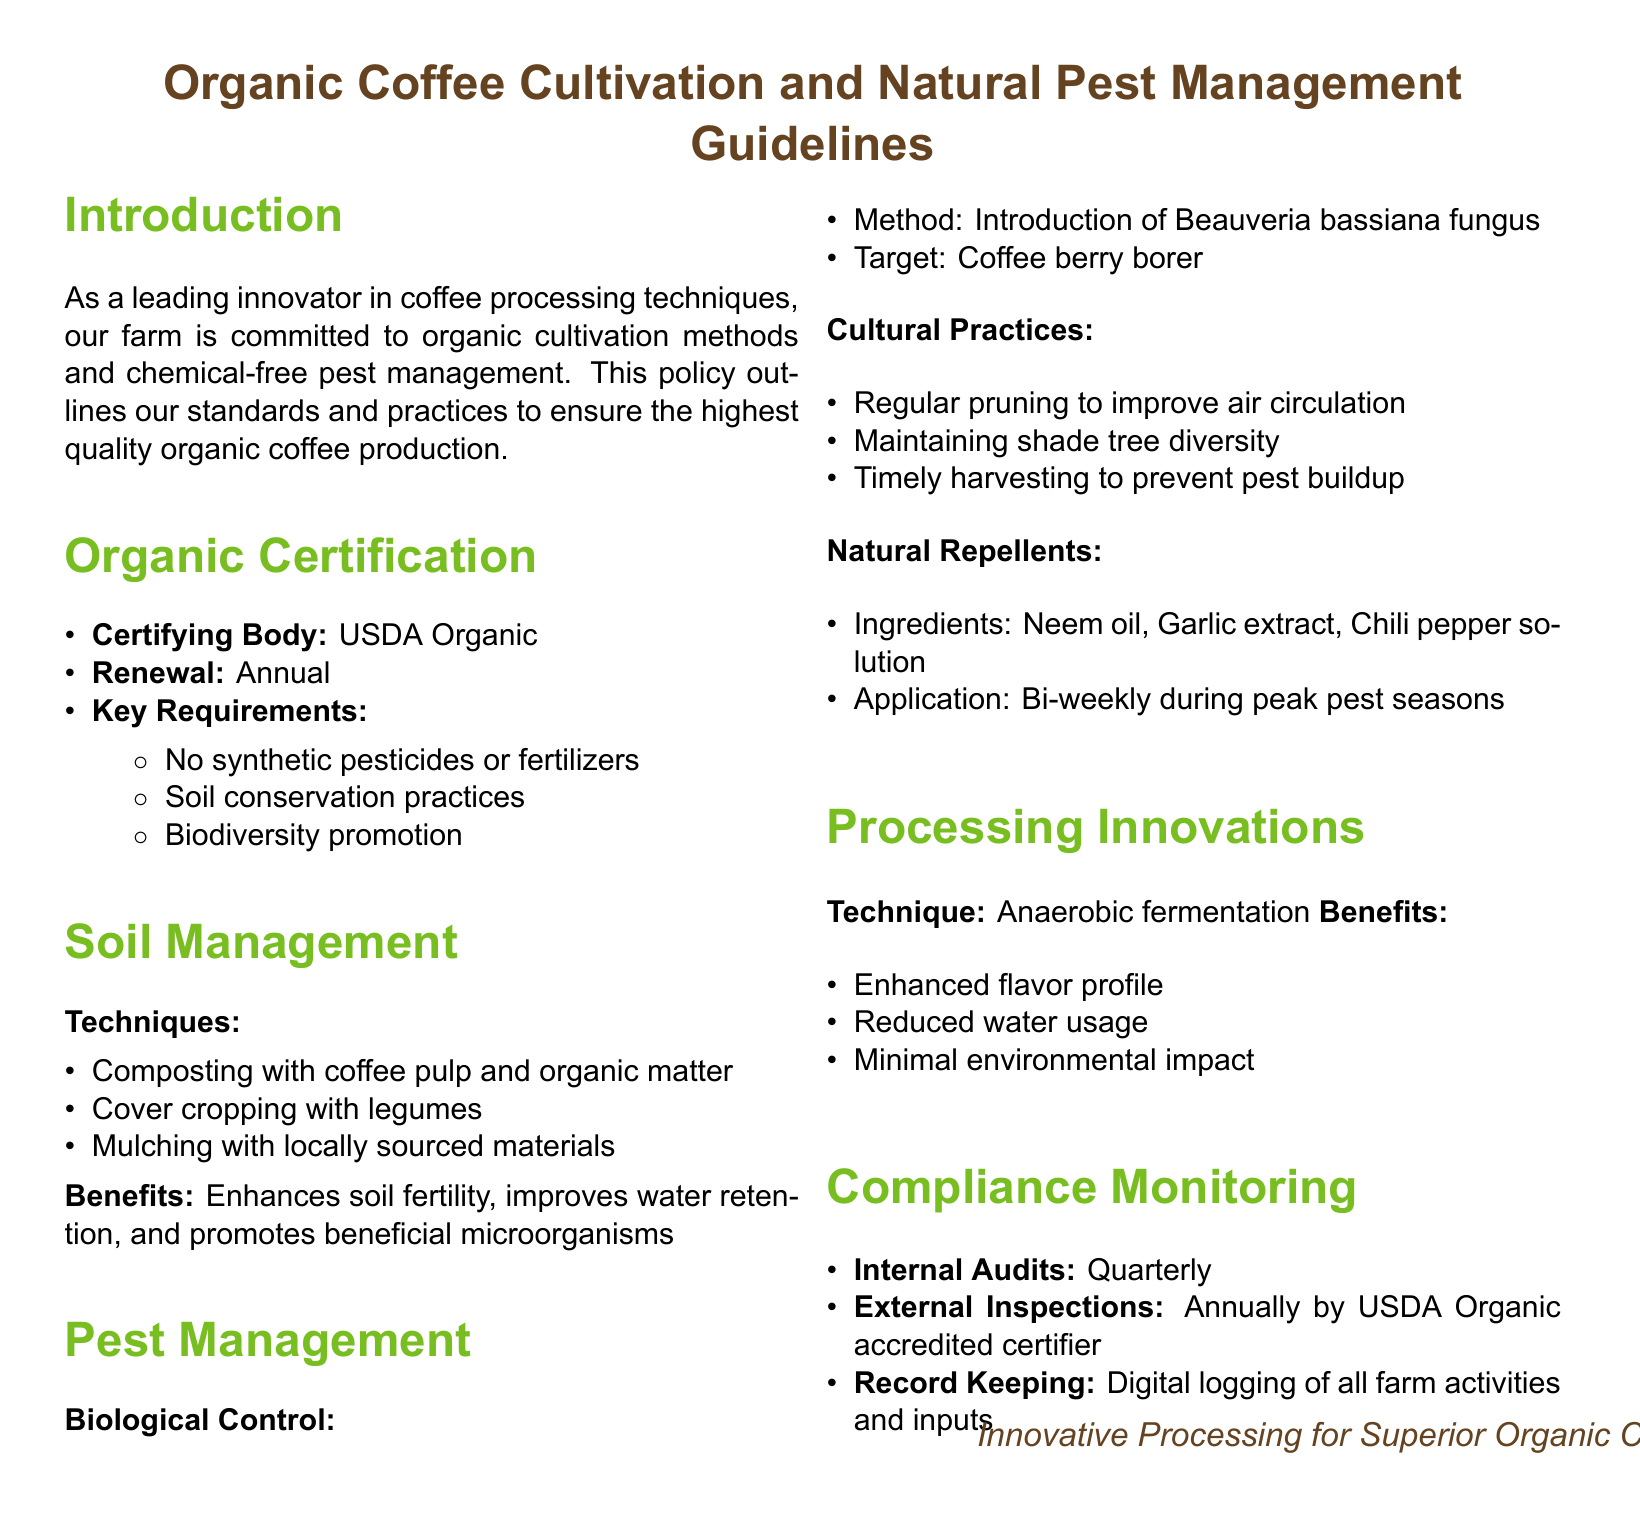What is the certifying body for organic coffee? The certifying body for organic coffee is mentioned in the Organic Certification section.
Answer: USDA Organic What is the key requirement for organic certification? The key requirements for organic certification include the conditions outlined in the Organic Certification section, specifically prohibiting synthetic pesticides or fertilizers.
Answer: No synthetic pesticides or fertilizers What pest is targeted by the biological control method? The specific pest targeted by the biological control method is found in the Pest Management section.
Answer: Coffee berry borer How often are internal audits conducted? The frequency of internal audits is described in the Compliance Monitoring section of the document.
Answer: Quarterly What technique is used in processing innovations? The processing innovation technique is mentioned under Processing Innovations.
Answer: Anaerobic fermentation What benefit is associated with cover cropping? The benefits associated with cover cropping can be inferred from the Soil Management section.
Answer: Improves water retention Which natural repellent ingredient is listed for application? The natural repellent ingredients are outlined in the Pest Management section, specifically provided for application during peak pest seasons.
Answer: Neem oil What is the benefit of anaerobic fermentation? One of the benefits of anaerobic fermentation is explained in the Processing Innovations section.
Answer: Enhanced flavor profile 